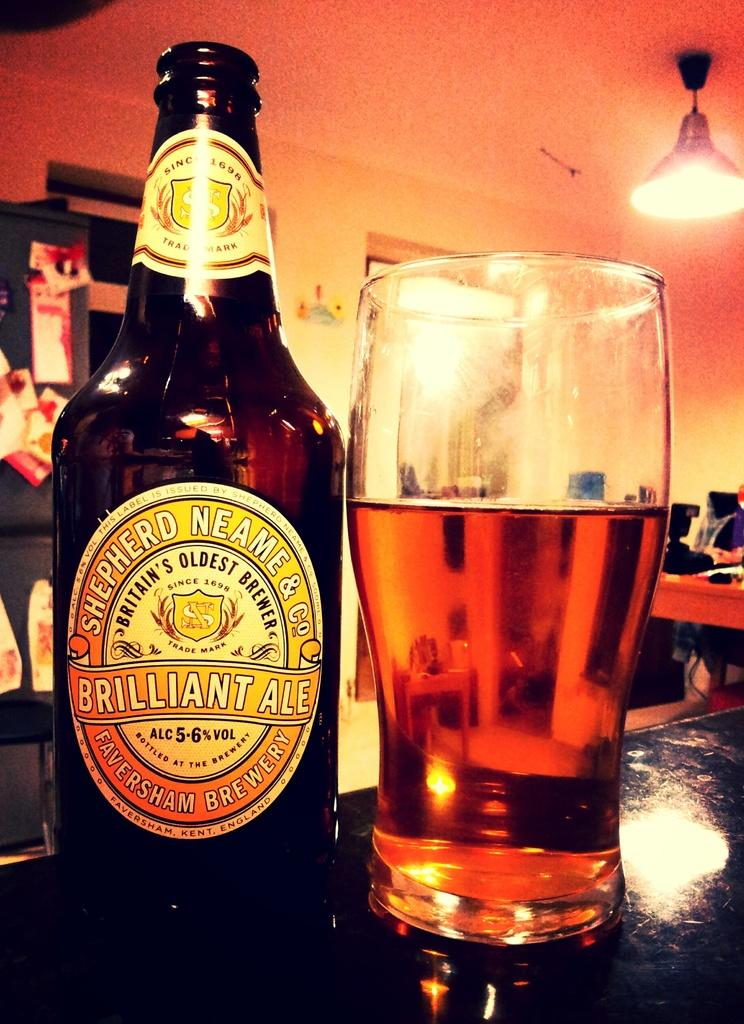Where is the image taken? The image is inside a room. What objects can be seen in the image? There is a bottle and a glass in the image. What piece of furniture is present at the right side of the image? There is a table at the right side of the image. What is the source of light in the image? There is a light at the top of the image. Who is the maid in the image? There is no maid present in the image. Who is the creator of the objects in the image? The creator of the objects in the image is not visible or identifiable in the image. 